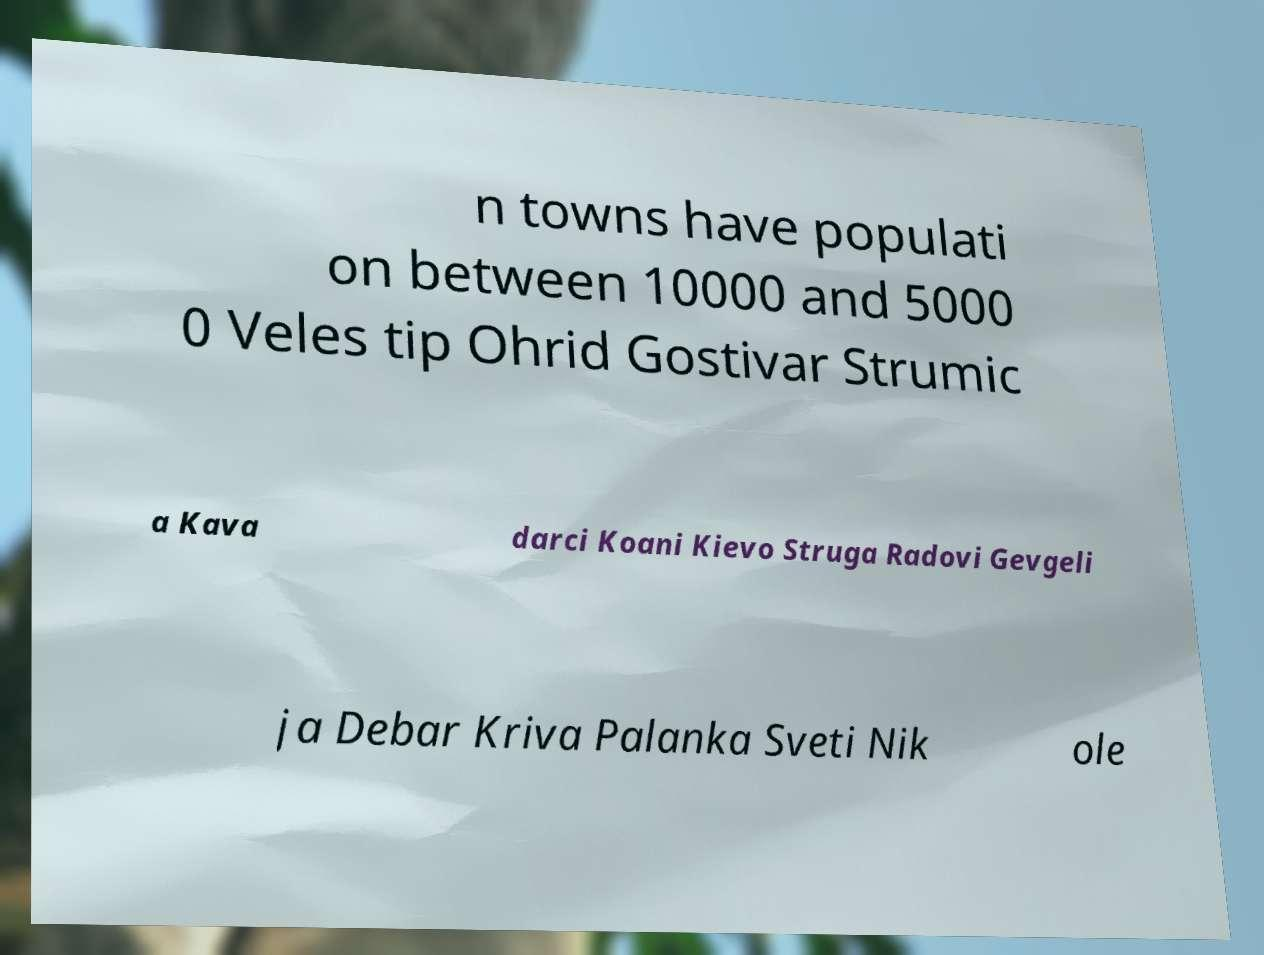What messages or text are displayed in this image? I need them in a readable, typed format. n towns have populati on between 10000 and 5000 0 Veles tip Ohrid Gostivar Strumic a Kava darci Koani Kievo Struga Radovi Gevgeli ja Debar Kriva Palanka Sveti Nik ole 